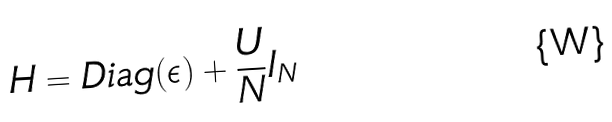Convert formula to latex. <formula><loc_0><loc_0><loc_500><loc_500>H = D i a g ( { \epsilon } ) + \frac { U } { N } { I } _ { N }</formula> 